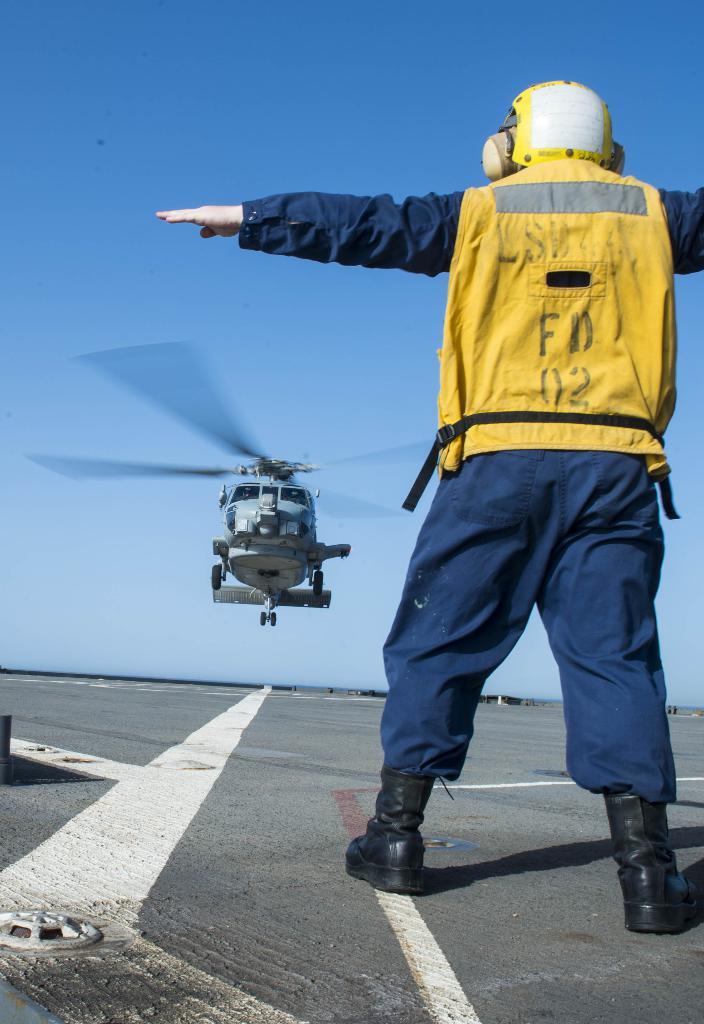This is a helepad place?
Your response must be concise. Yes. 